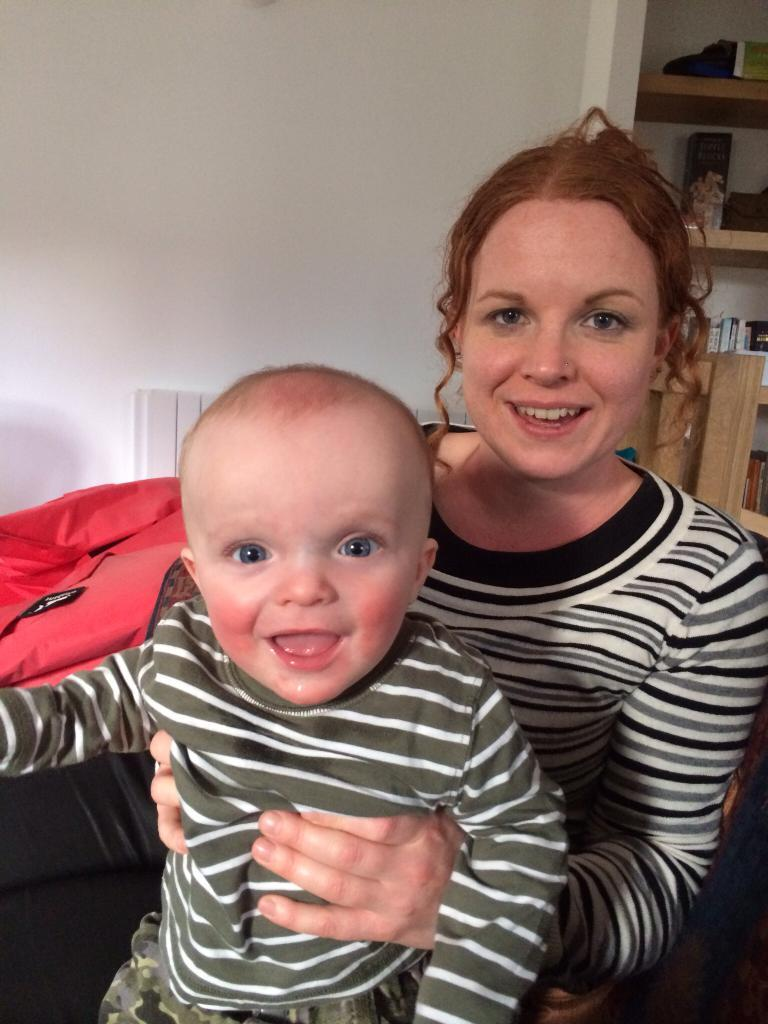What is the woman doing in the image? The woman is holding a child in the image. What can be seen behind the woman and child? There are shelves visible in the image. What piece of furniture is present in the image? There is a chair in the image. What type of structure is visible in the image? There is a wall in the image. What type of muscle is being flexed by the woman in the image? There is no indication of any muscle flexing in the image; the woman is simply holding a child. 